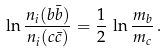Convert formula to latex. <formula><loc_0><loc_0><loc_500><loc_500>\ln { \frac { n _ { i } ( b \bar { b } ) } { n _ { i } ( c \bar { c } ) } } = \frac { 1 } { 2 } \, \ln { \frac { m _ { b } } { m _ { c } } } \, .</formula> 